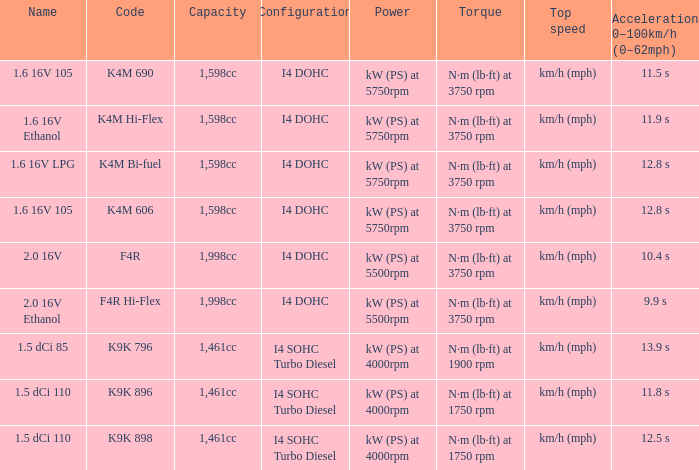What is the capacity of code f4r? 1,998cc. 